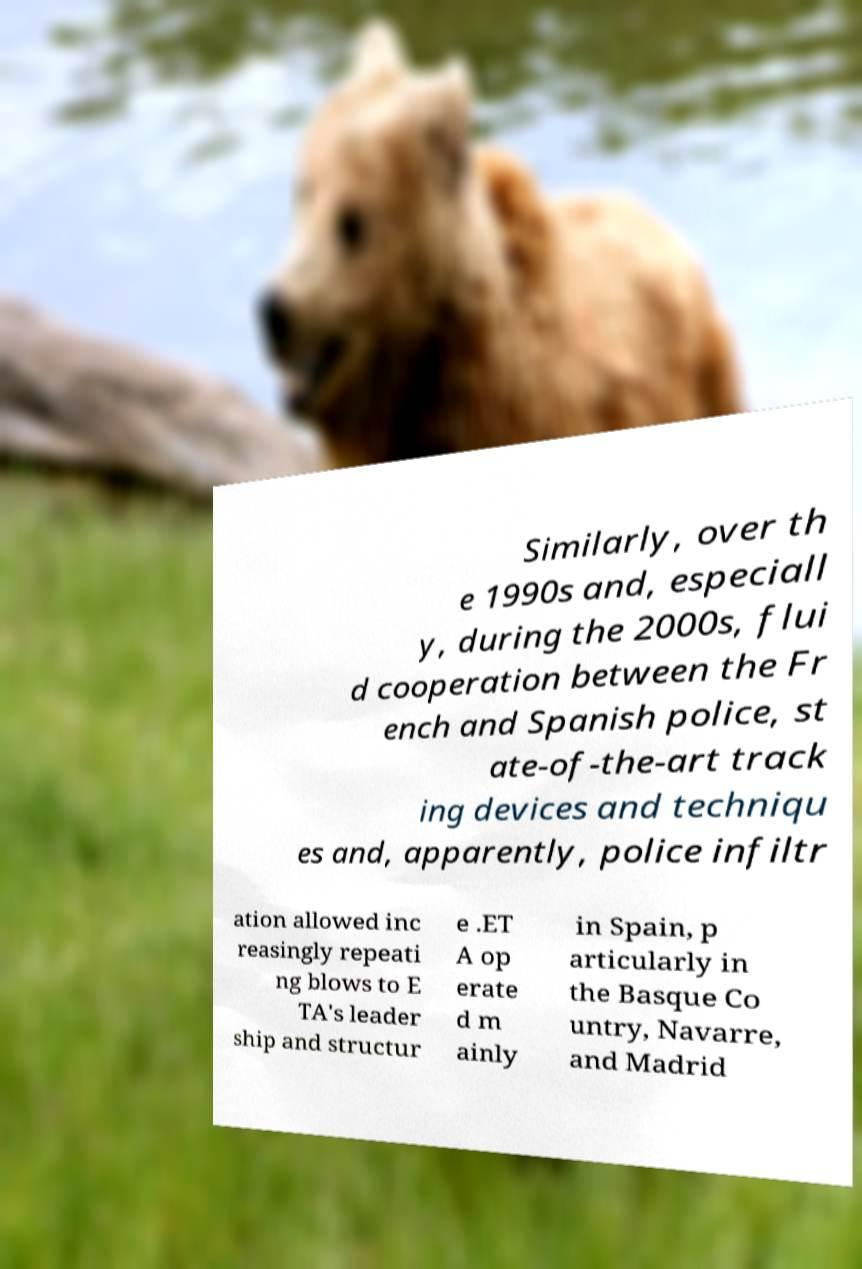What messages or text are displayed in this image? I need them in a readable, typed format. Similarly, over th e 1990s and, especiall y, during the 2000s, flui d cooperation between the Fr ench and Spanish police, st ate-of-the-art track ing devices and techniqu es and, apparently, police infiltr ation allowed inc reasingly repeati ng blows to E TA's leader ship and structur e .ET A op erate d m ainly in Spain, p articularly in the Basque Co untry, Navarre, and Madrid 